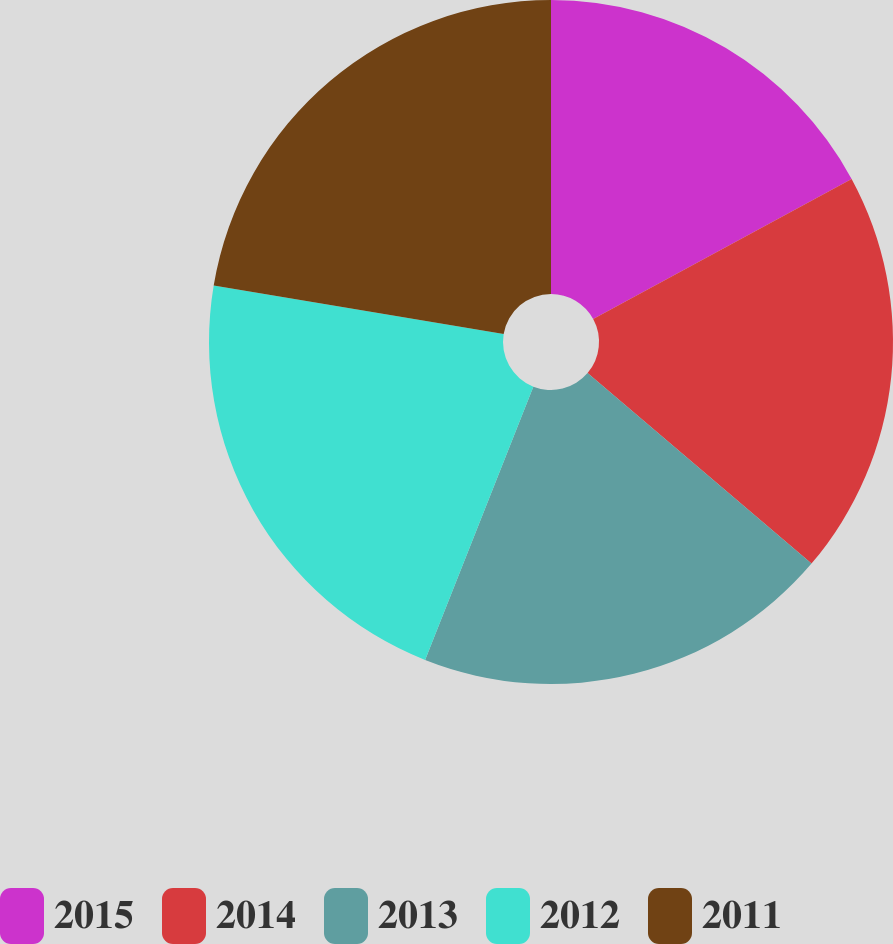<chart> <loc_0><loc_0><loc_500><loc_500><pie_chart><fcel>2015<fcel>2014<fcel>2013<fcel>2012<fcel>2011<nl><fcel>17.09%<fcel>19.13%<fcel>19.78%<fcel>21.64%<fcel>22.36%<nl></chart> 